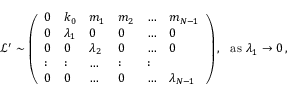Convert formula to latex. <formula><loc_0><loc_0><loc_500><loc_500>\begin{array} { r } { \ \mathcal { L } ^ { \prime } \sim \left ( \begin{array} { l l l l l l } { 0 } & { k _ { 0 } } & { m _ { 1 } } & { m _ { 2 } } & { \dots } & { m _ { N - 1 } } \\ { 0 } & { \lambda _ { 1 } } & { 0 } & { 0 } & { \dots } & { 0 } \\ { 0 } & { 0 } & { \lambda _ { 2 } } & { 0 } & { \dots } & { 0 } \\ { \colon } & { \colon } & { \dots } & { \colon } & { \colon } \\ { 0 } & { 0 } & { \dots } & { 0 } & { \dots } & { \lambda _ { N - 1 } } \end{array} \right ) , a s \lambda _ { 1 } \rightarrow 0 \, , } \end{array}</formula> 